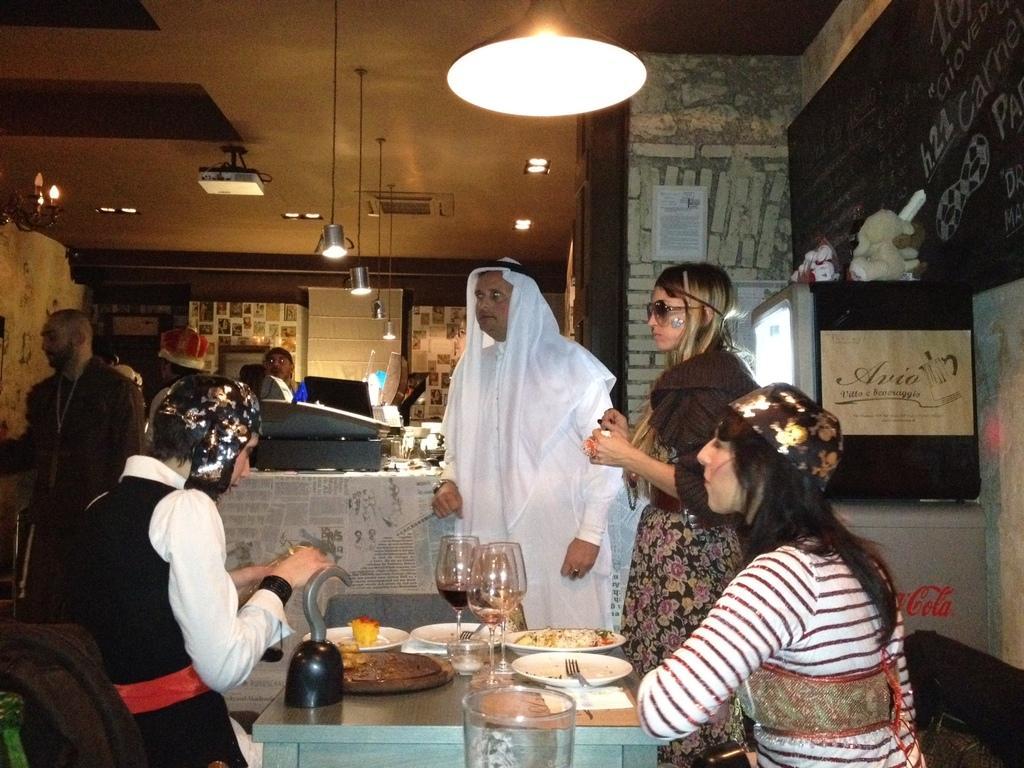Describe this image in one or two sentences. In this image I can see group of people some are sitting and some are standing, in front I can see few plates, glasses, spoons on the table, I can also see a person standing wearing white color dress. Background I can see a paper attached to the wall and the wall is in gray color and I can also see few lights. 